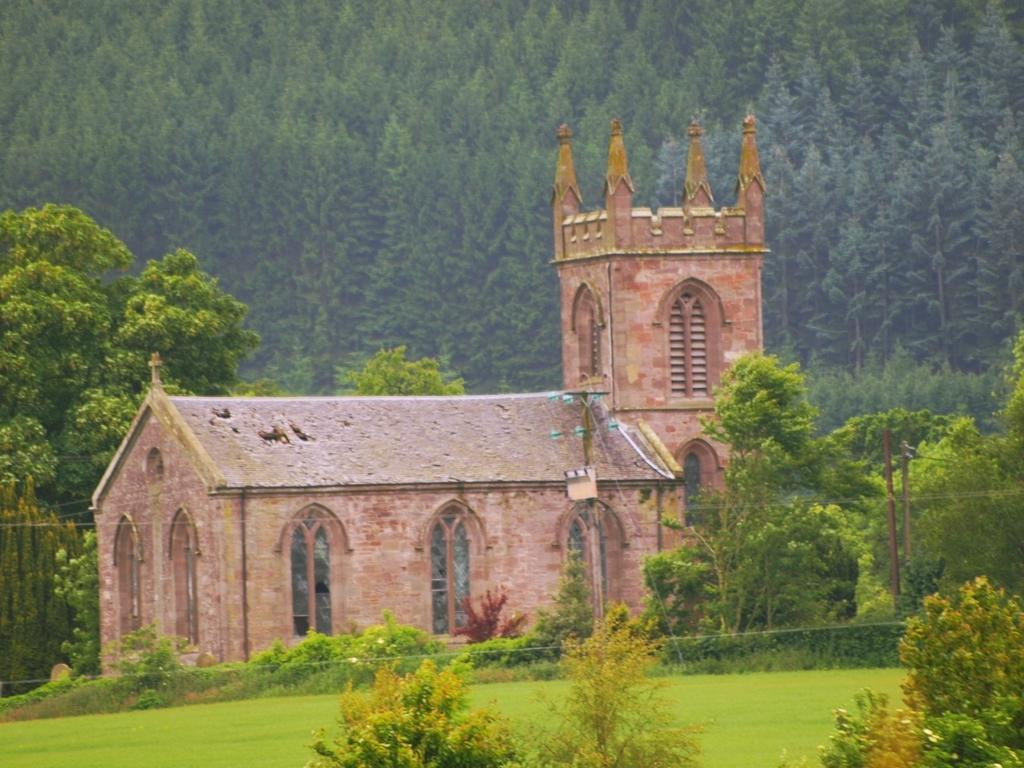What is the color of the grass in the image? The grass in the image is green. What type of plants can be seen in the image? There are green color plants in the image. What structure is visible in the image? There is a house in the image. What type of vegetation is present in the background of the image? There are green color trees in the background of the image. What type of lettuce is being used to make oil in the image? There is no lettuce or oil present in the image. How many pears are hanging from the trees in the image? There are no pears visible in the image; only green color trees are present. 